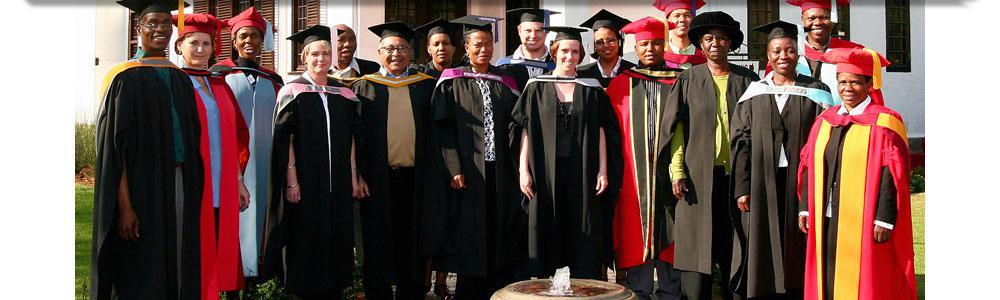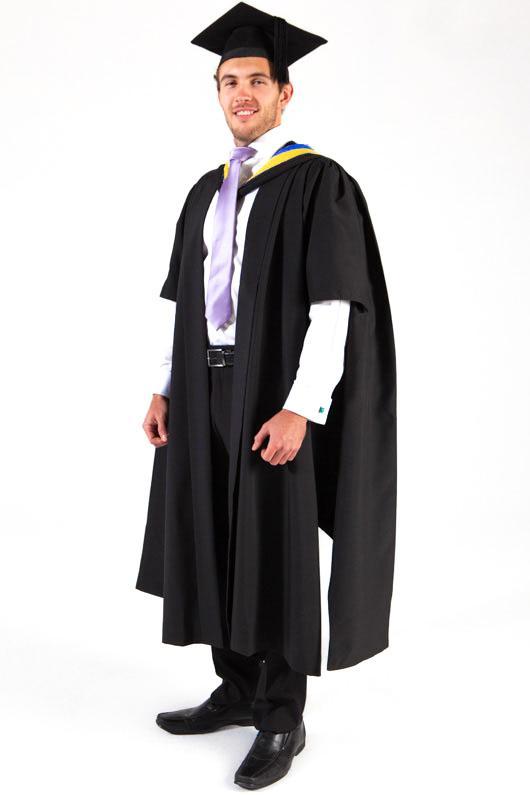The first image is the image on the left, the second image is the image on the right. Assess this claim about the two images: "The student in the right image is wearing a purple tie.". Correct or not? Answer yes or no. Yes. The first image is the image on the left, the second image is the image on the right. Given the left and right images, does the statement "A woman stands with one hand on her hip." hold true? Answer yes or no. No. 